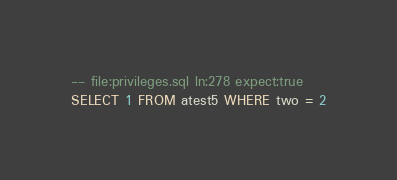Convert code to text. <code><loc_0><loc_0><loc_500><loc_500><_SQL_>-- file:privileges.sql ln:278 expect:true
SELECT 1 FROM atest5 WHERE two = 2
</code> 